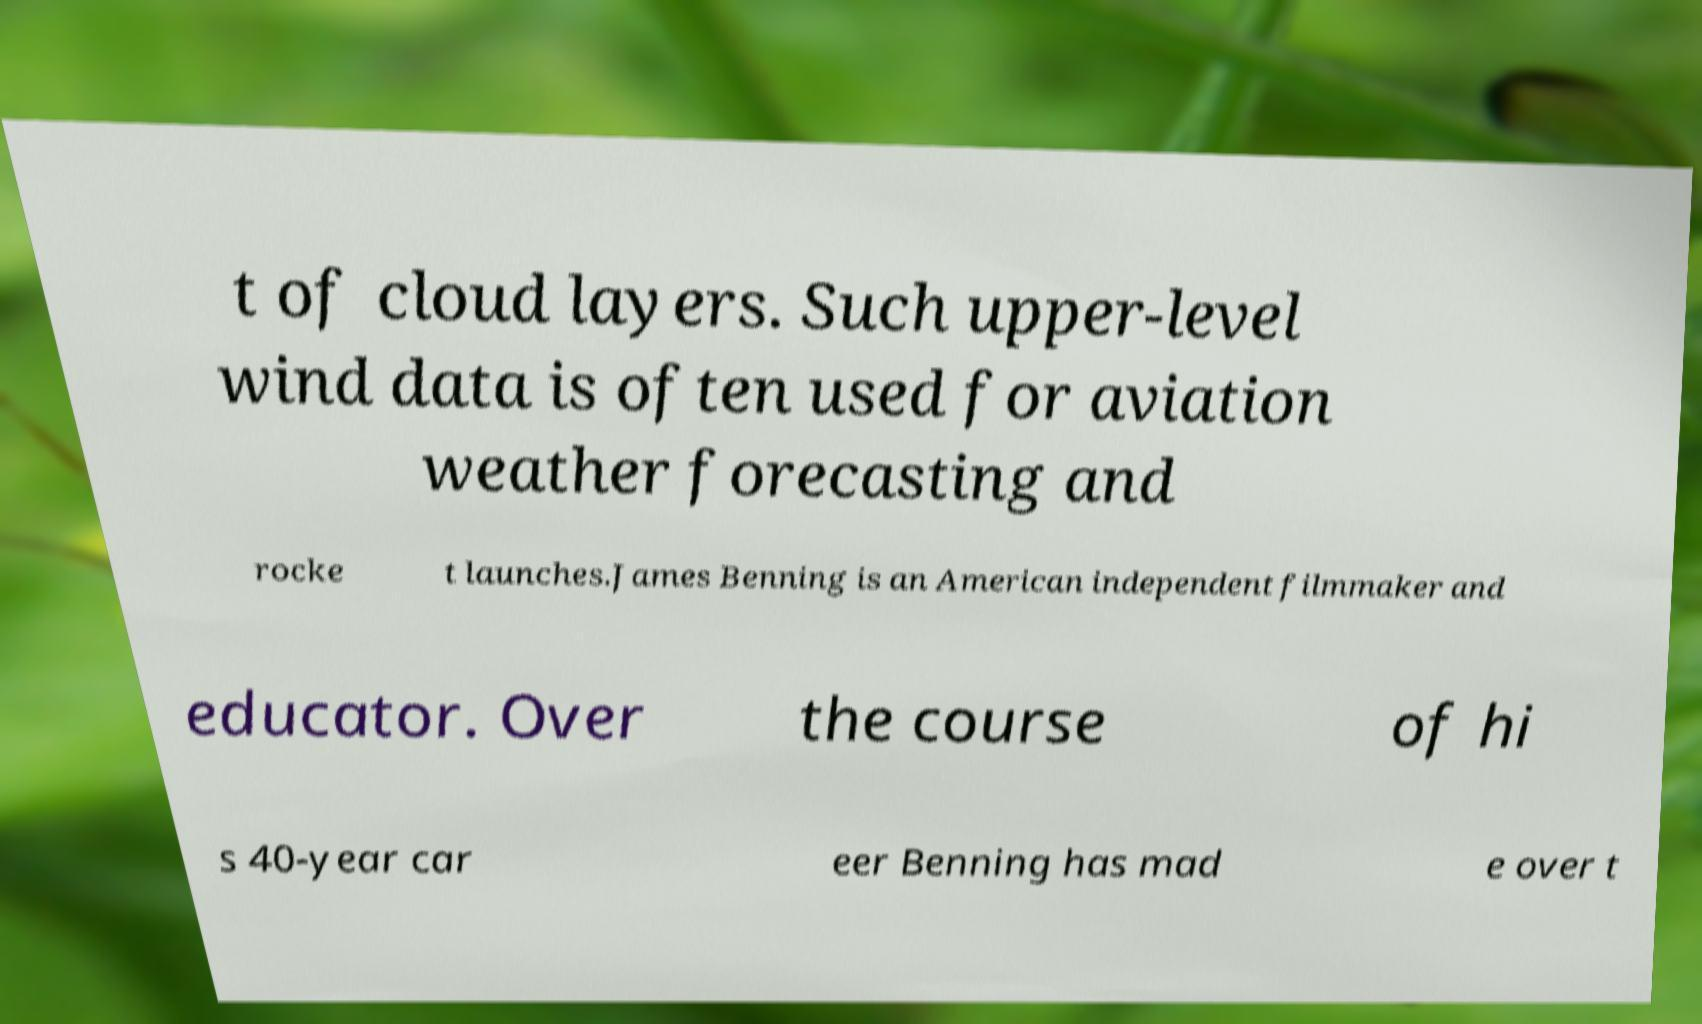Can you accurately transcribe the text from the provided image for me? t of cloud layers. Such upper-level wind data is often used for aviation weather forecasting and rocke t launches.James Benning is an American independent filmmaker and educator. Over the course of hi s 40-year car eer Benning has mad e over t 